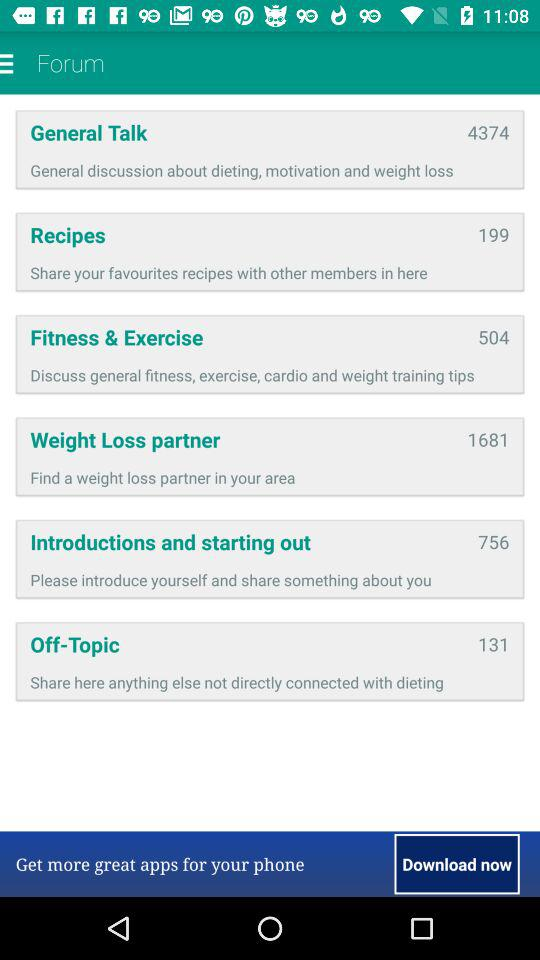How many topics are there in the forum?
Answer the question using a single word or phrase. 6 